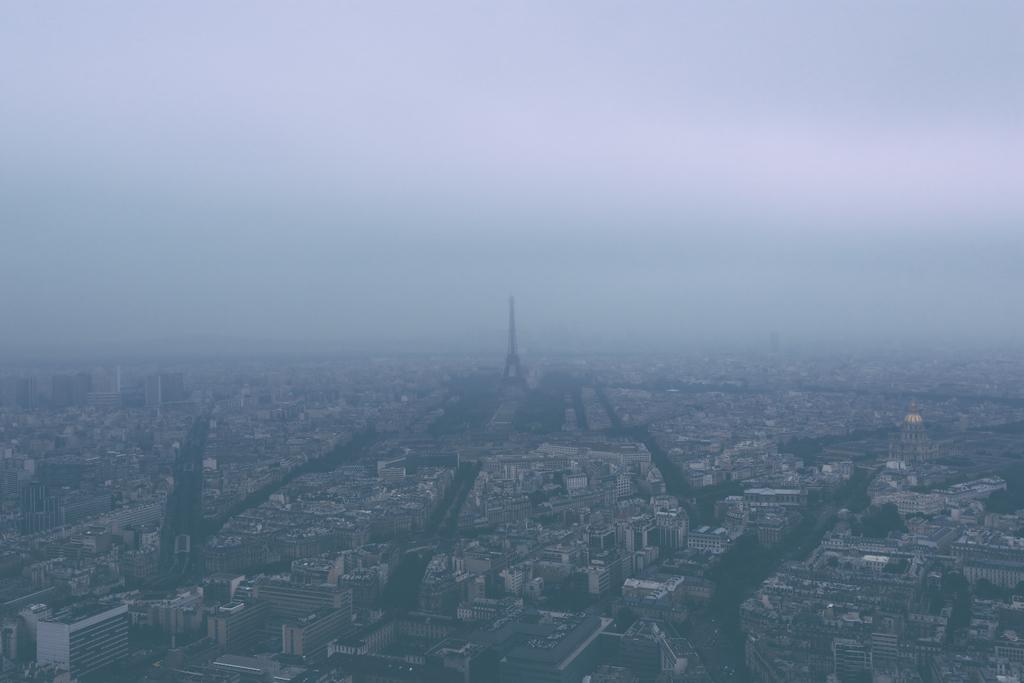Could you give a brief overview of what you see in this image? In this image we can see few buildings, a tower and the sky in the background. 